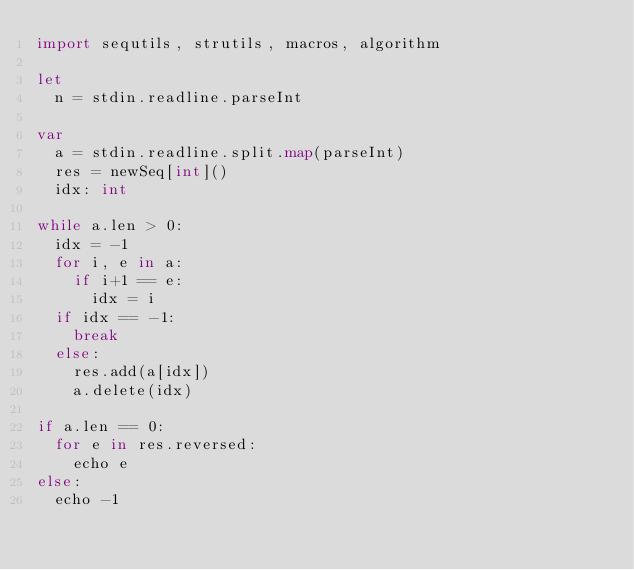Convert code to text. <code><loc_0><loc_0><loc_500><loc_500><_Nim_>import sequtils, strutils, macros, algorithm

let
  n = stdin.readline.parseInt

var
  a = stdin.readline.split.map(parseInt)
  res = newSeq[int]()
  idx: int

while a.len > 0:
  idx = -1
  for i, e in a:
    if i+1 == e:
      idx = i
  if idx == -1:
    break
  else:
    res.add(a[idx])
    a.delete(idx)

if a.len == 0:
  for e in res.reversed:
    echo e
else:
  echo -1</code> 